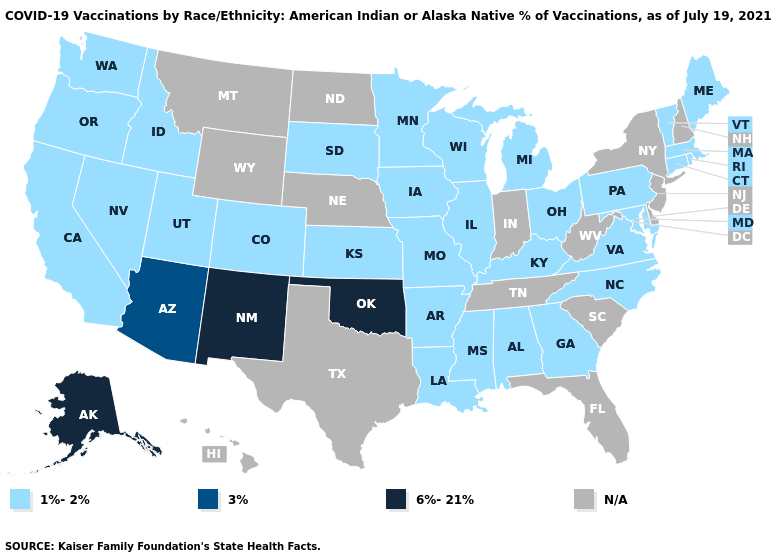Does Georgia have the lowest value in the South?
Short answer required. Yes. Which states have the highest value in the USA?
Quick response, please. Alaska, New Mexico, Oklahoma. Does Nevada have the lowest value in the West?
Concise answer only. Yes. How many symbols are there in the legend?
Short answer required. 4. Name the states that have a value in the range 6%-21%?
Concise answer only. Alaska, New Mexico, Oklahoma. Name the states that have a value in the range 6%-21%?
Give a very brief answer. Alaska, New Mexico, Oklahoma. Name the states that have a value in the range 1%-2%?
Be succinct. Alabama, Arkansas, California, Colorado, Connecticut, Georgia, Idaho, Illinois, Iowa, Kansas, Kentucky, Louisiana, Maine, Maryland, Massachusetts, Michigan, Minnesota, Mississippi, Missouri, Nevada, North Carolina, Ohio, Oregon, Pennsylvania, Rhode Island, South Dakota, Utah, Vermont, Virginia, Washington, Wisconsin. Name the states that have a value in the range 3%?
Quick response, please. Arizona. Does the map have missing data?
Concise answer only. Yes. What is the lowest value in states that border West Virginia?
Concise answer only. 1%-2%. Which states hav the highest value in the South?
Give a very brief answer. Oklahoma. Name the states that have a value in the range 1%-2%?
Quick response, please. Alabama, Arkansas, California, Colorado, Connecticut, Georgia, Idaho, Illinois, Iowa, Kansas, Kentucky, Louisiana, Maine, Maryland, Massachusetts, Michigan, Minnesota, Mississippi, Missouri, Nevada, North Carolina, Ohio, Oregon, Pennsylvania, Rhode Island, South Dakota, Utah, Vermont, Virginia, Washington, Wisconsin. Which states have the lowest value in the South?
Concise answer only. Alabama, Arkansas, Georgia, Kentucky, Louisiana, Maryland, Mississippi, North Carolina, Virginia. Which states hav the highest value in the Northeast?
Write a very short answer. Connecticut, Maine, Massachusetts, Pennsylvania, Rhode Island, Vermont. 